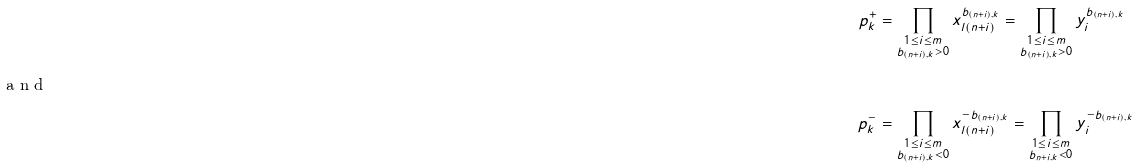Convert formula to latex. <formula><loc_0><loc_0><loc_500><loc_500>p _ { k } ^ { + } & = \prod _ { \substack { 1 \leq i \leq m \\ b _ { ( n + i ) , k } > 0 } } x _ { l ( n + i ) } ^ { b _ { ( n + i ) , k } } = \prod _ { \substack { 1 \leq i \leq m \\ b _ { ( n + i ) , k } > 0 } } y _ { i } ^ { b _ { ( n + i ) , k } } \\ \intertext { a n d } p _ { k } ^ { - } & = \prod _ { \substack { 1 \leq i \leq m \\ b _ { ( n + i ) , k } < 0 } } x _ { l ( n + i ) } ^ { - b _ { ( n + i ) , k } } = \prod _ { \substack { 1 \leq i \leq m \\ b _ { n + i , k } < 0 } } y _ { i } ^ { - b _ { ( n + i ) , k } }</formula> 